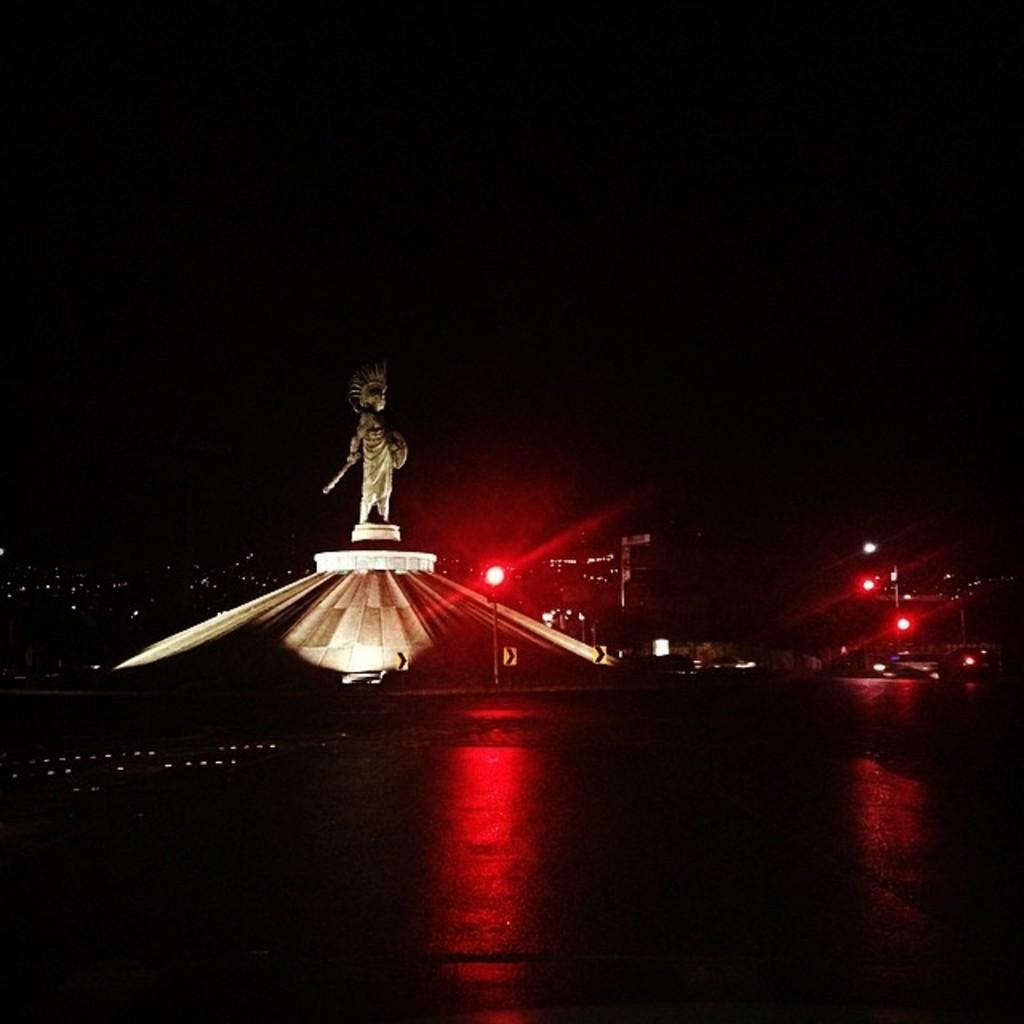What is the main subject of the image? The main subject of the image is a statue of a person on a tomb. Are there any other objects or structures visible in the image? Yes, there are street lights in the image. What type of cake is being served at the apparatus in the image? There is no apparatus or cake present in the image. 